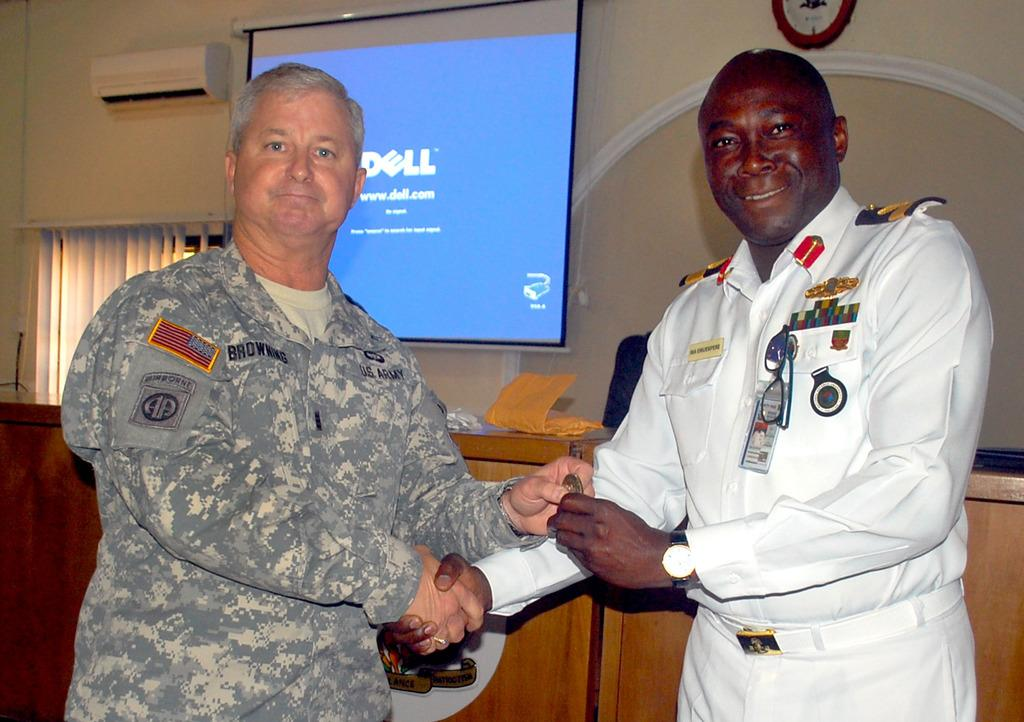<image>
Share a concise interpretation of the image provided. Two men shake hands with a screen in the background with the make Dell shown on it. 